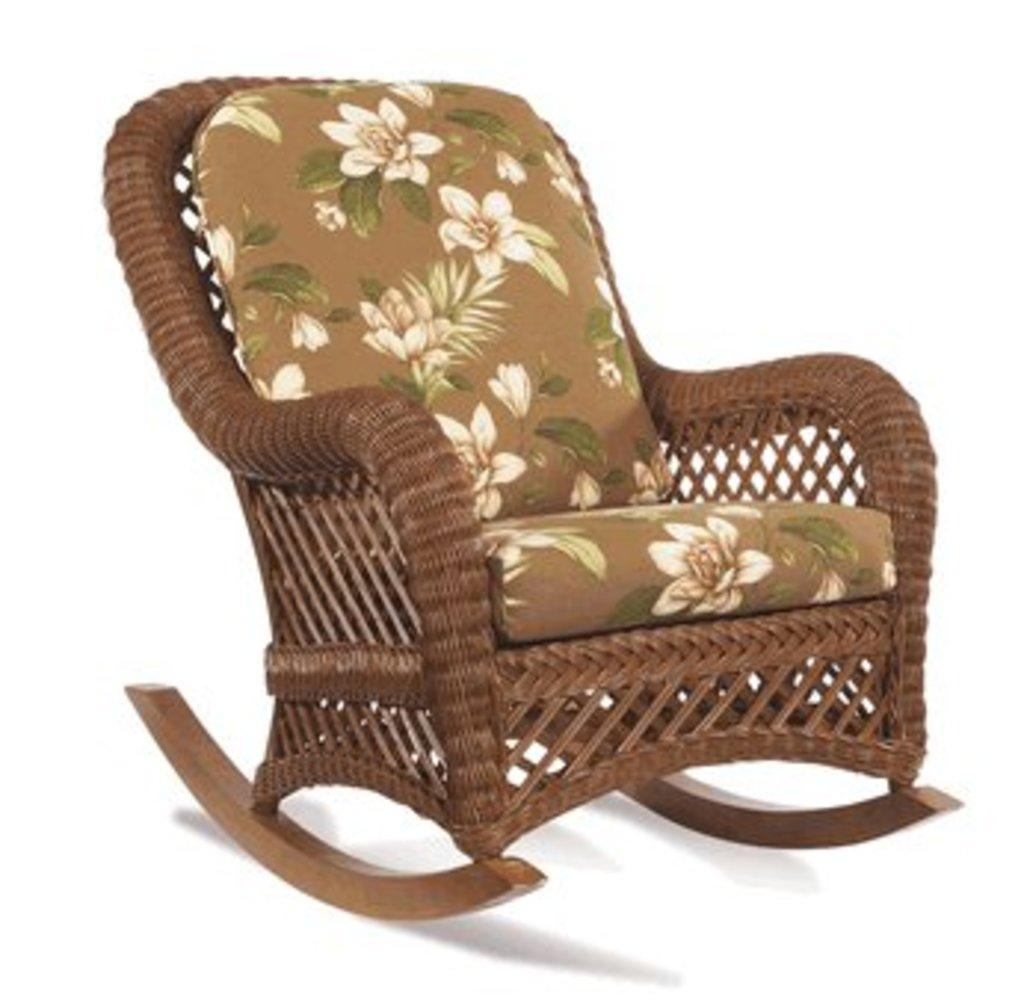What type of furniture is present in the image? There is a chair in the image. What color is the background of the image? The background of the image is white. What type of mint is growing on the chair in the image? There is no mint present in the image; it only features a chair and a white background. 